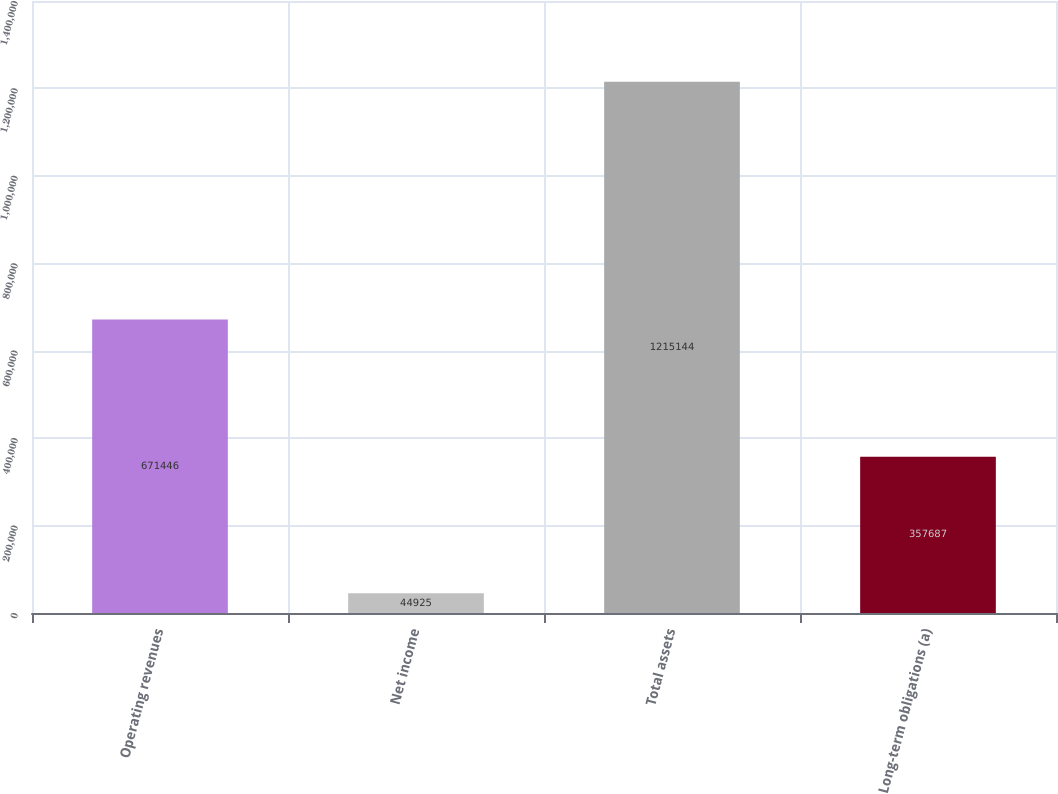<chart> <loc_0><loc_0><loc_500><loc_500><bar_chart><fcel>Operating revenues<fcel>Net income<fcel>Total assets<fcel>Long-term obligations (a)<nl><fcel>671446<fcel>44925<fcel>1.21514e+06<fcel>357687<nl></chart> 